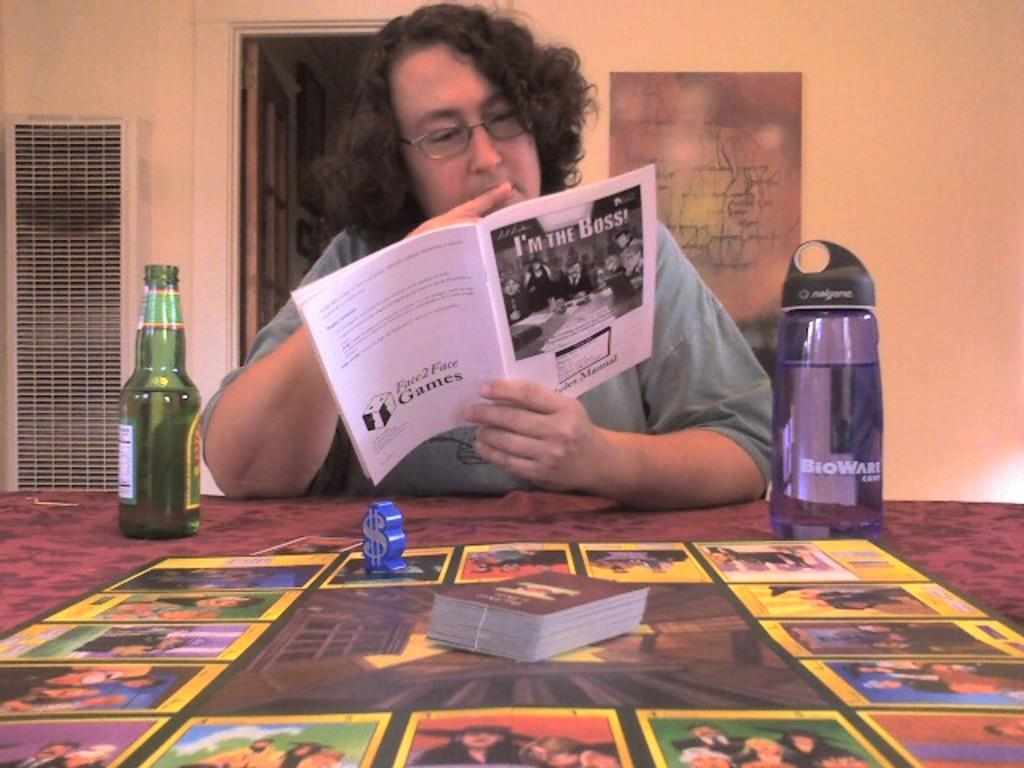<image>
Give a short and clear explanation of the subsequent image. A man is sitting at a table reading a magazine titled I'm the boss.. 